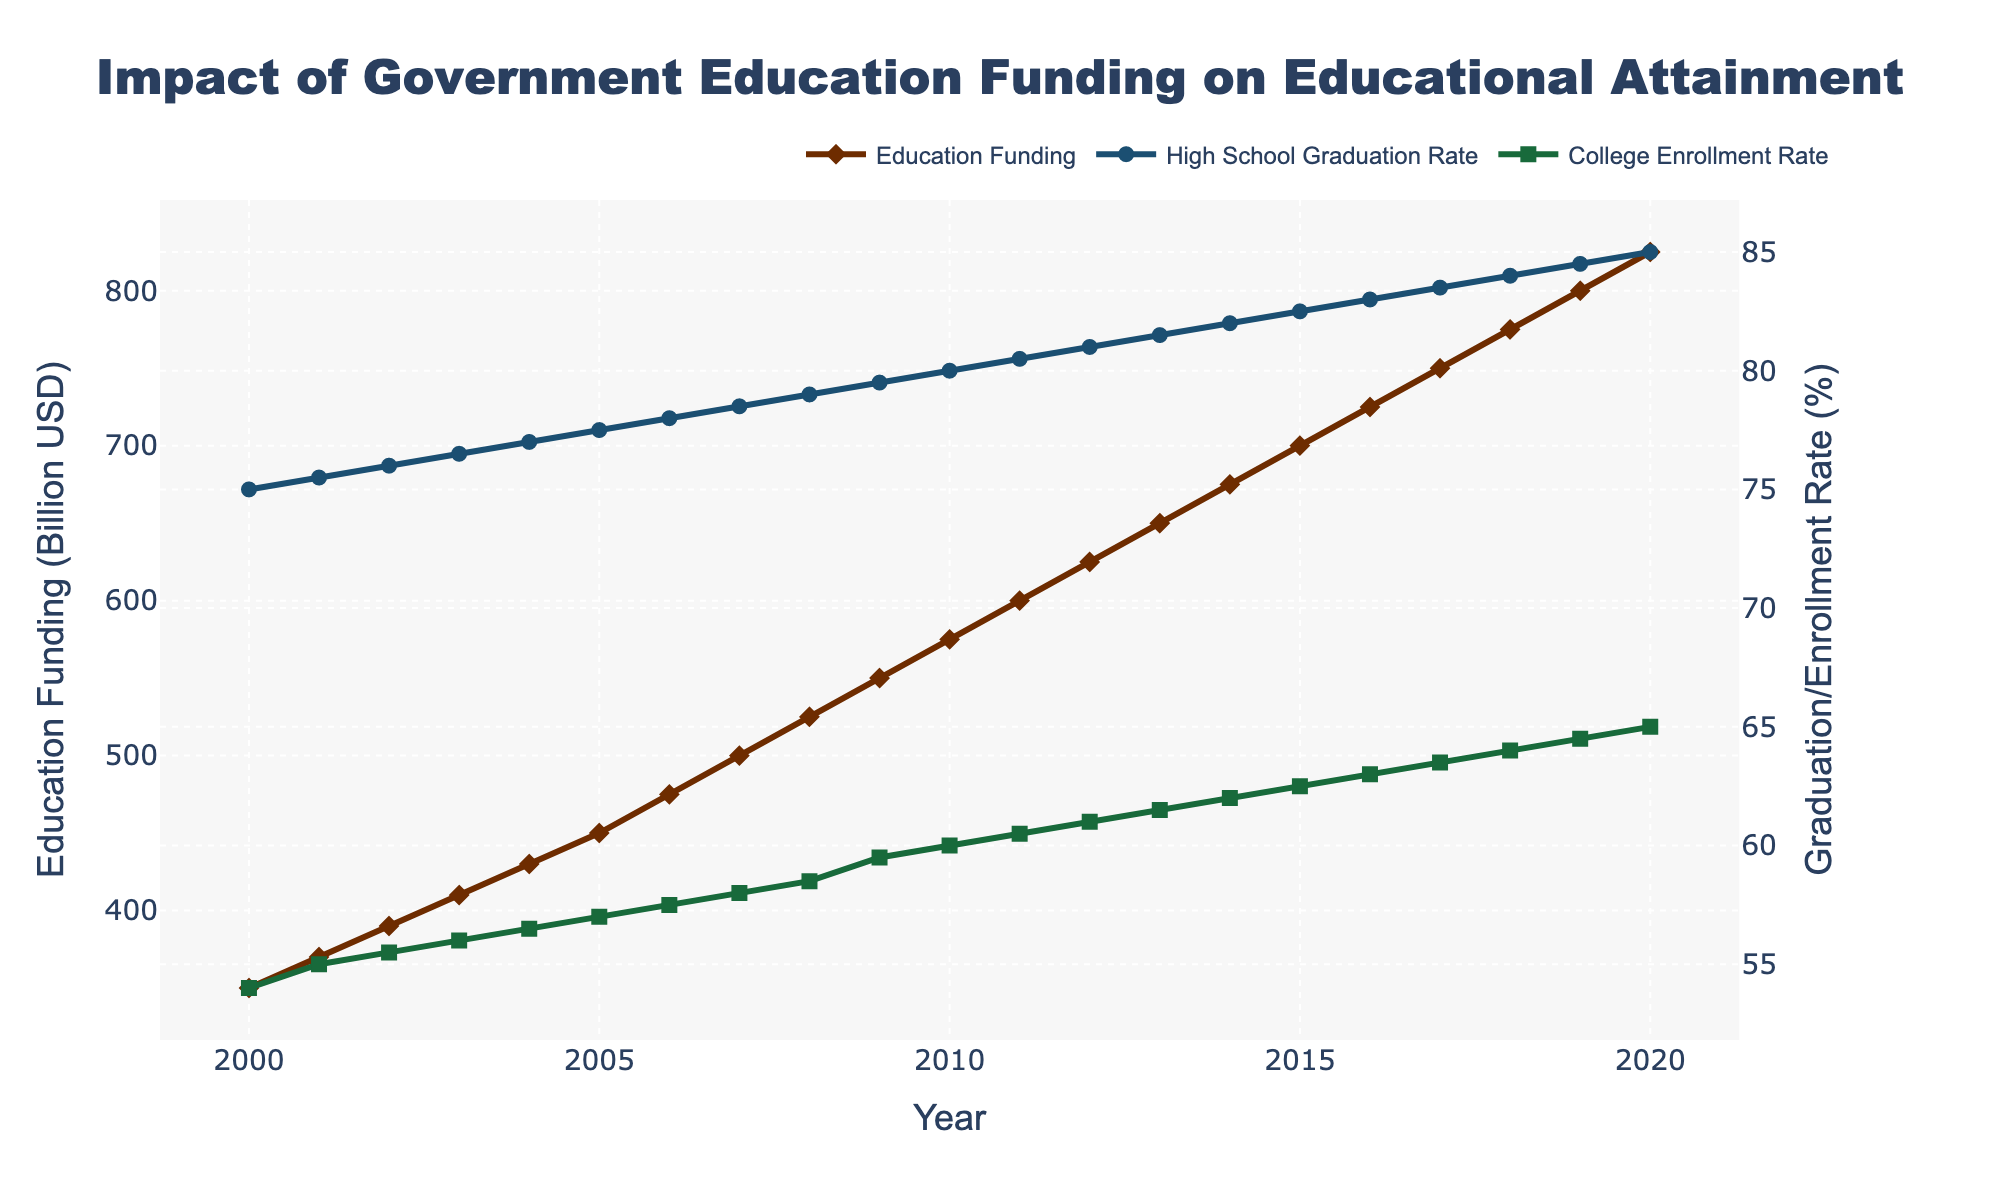What's the title of the plot? The title is displayed prominently at the top center of the plot. It reads "Impact of Government Education Funding on Educational Attainment".
Answer: Impact of Government Education Funding on Educational Attainment What are the units of the y-axis on the left side of the plot? The left y-axis title reads "Education Funding (Billion USD)", indicating that the values are measured in billions of US dollars.
Answer: Billion USD How did the college enrollment rate change from 2000 to 2020? Refer to the green line with square markers representing the college enrollment rate. It increased from 54% in 2000 to 65% in 2020.
Answer: It increased by 11 percentage points What was the trend in high school graduation rates over the given period? Examine the blue line with circle markers representing high school graduation rates. The trend shows a consistent increase from 75% in 2000 to 85% in 2020.
Answer: Consistent increase In which year did government education funding reach 600 billion USD? Locate the brown line with diamond markers. Government education funding reached 600 billion USD in 2011.
Answer: 2011 Compare the government education funding in 2005 and 2010. Which year had higher funding and by how much? In 2005, funding was 450 billion USD, and in 2010, it was 575 billion USD. 2010 had higher funding by 125 billion USD.
Answer: 2010 by 125 billion USD What is the relationship between the increase in government education funding and high school graduation rates? Observe how both the brown line (funding) and blue line (graduation rate) trend upward. As funding increases, the graduation rate similarly increases.
Answer: Positive correlation Determine the average college enrollment rate from 2000 to 2020. Sum all the yearly enrollment rates and divide by the total number of years (21). The average rate can be calculated as (54 + 55 +... + 65)/21.
Answer: 59.5% What is the difference between high school graduation and college enrollment rates in 2020? Check the graph for 2020. High school graduation rate is 85% and college enrollment rate is 65%. The difference is 85% - 65%.
Answer: 20 percentage points Which variable showed the greatest overall rate of increase from 2000 to 2020, and what was that rate? Calculate the change for each variable: Funding: 825 - 350 = 475 billion USD; HS graduation rate: 85% - 75% = 10 percentage points; College enrollment rate: 65% - 54% = 11 percentage points. The funding had the greatest overall increase of 475 billion USD.
Answer: Government education funding, 475 billion USD 